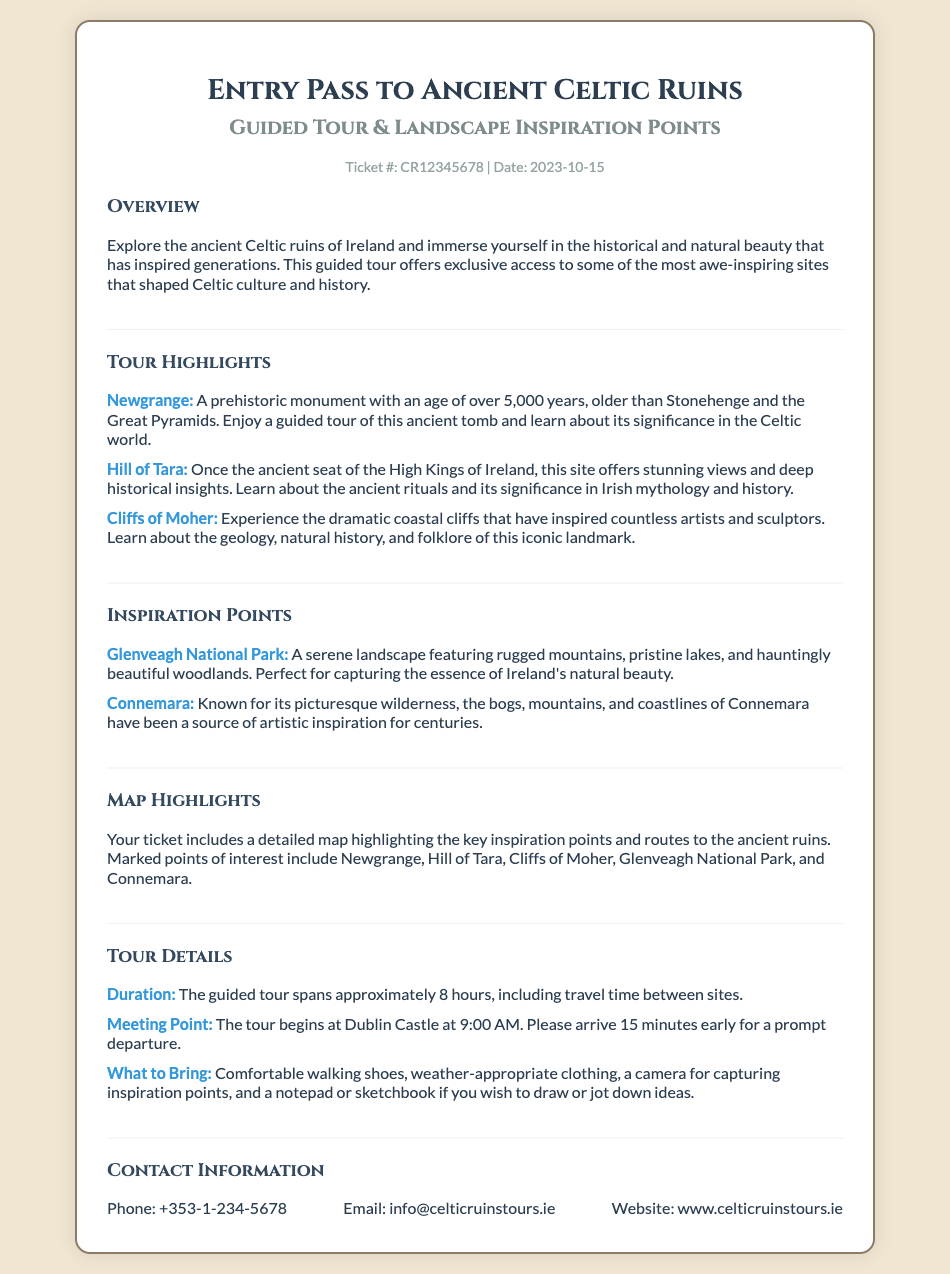What is the ticket number? The ticket number is a unique identifier provided in the document, which is CR12345678.
Answer: CR12345678 What is the duration of the guided tour? The duration of the guided tour is specified in the document, lasting approximately 8 hours.
Answer: 8 hours Where does the tour begin? The meeting point for the tour is indicated in the document as Dublin Castle.
Answer: Dublin Castle What is a highlight of the tour? A highlight of the tour is a unique landmark mentioned, for example, Newgrange.
Answer: Newgrange What should participants bring? The document specifies items to bring, including comfortable walking shoes.
Answer: Comfortable walking shoes What is included with the ticket? The document mentions that a detailed map is included with the ticket.
Answer: A detailed map What can be sketched or noted down during the tour? The document suggests bringing a sketchbook or notepad for jotting down inspirations.
Answer: A sketchbook or notepad Which natural park is listed as an inspiration point? The document lists Glenveagh National Park as an inspiration point.
Answer: Glenveagh National Park When is the tour date? The tour date is provided in the document as 2023-10-15.
Answer: 2023-10-15 